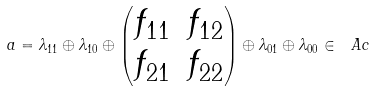Convert formula to latex. <formula><loc_0><loc_0><loc_500><loc_500>a = \lambda _ { 1 1 } \oplus \lambda _ { 1 0 } \oplus \begin{pmatrix} f _ { 1 1 } & f _ { 1 2 } \\ f _ { 2 1 } & f _ { 2 2 } \end{pmatrix} \oplus \lambda _ { 0 1 } \oplus \lambda _ { 0 0 } \in \ A c</formula> 